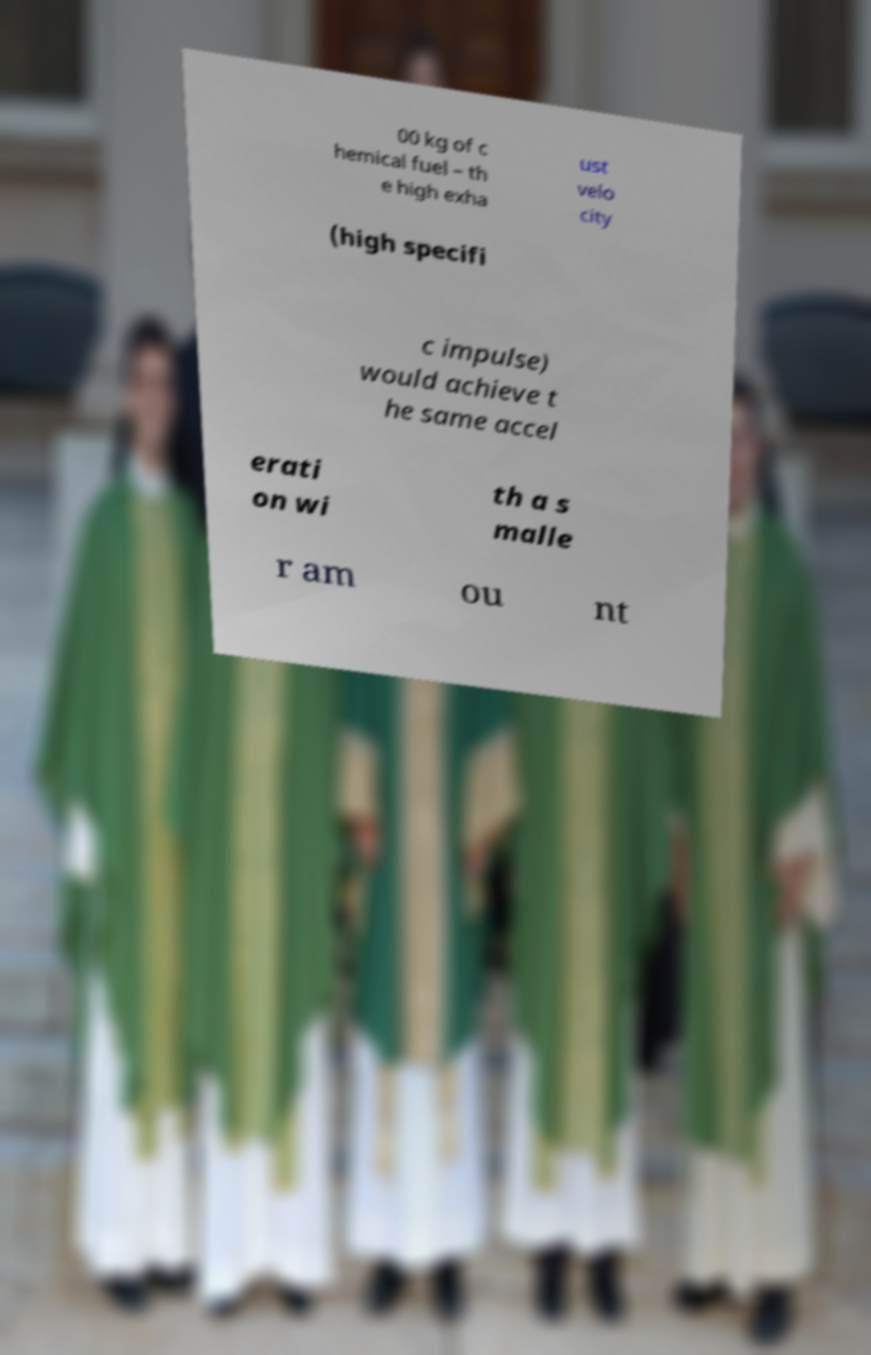I need the written content from this picture converted into text. Can you do that? 00 kg of c hemical fuel – th e high exha ust velo city (high specifi c impulse) would achieve t he same accel erati on wi th a s malle r am ou nt 